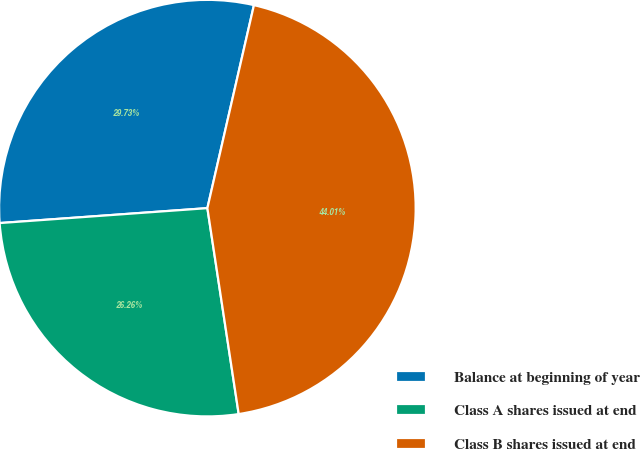Convert chart. <chart><loc_0><loc_0><loc_500><loc_500><pie_chart><fcel>Balance at beginning of year<fcel>Class A shares issued at end<fcel>Class B shares issued at end<nl><fcel>29.73%<fcel>26.26%<fcel>44.01%<nl></chart> 